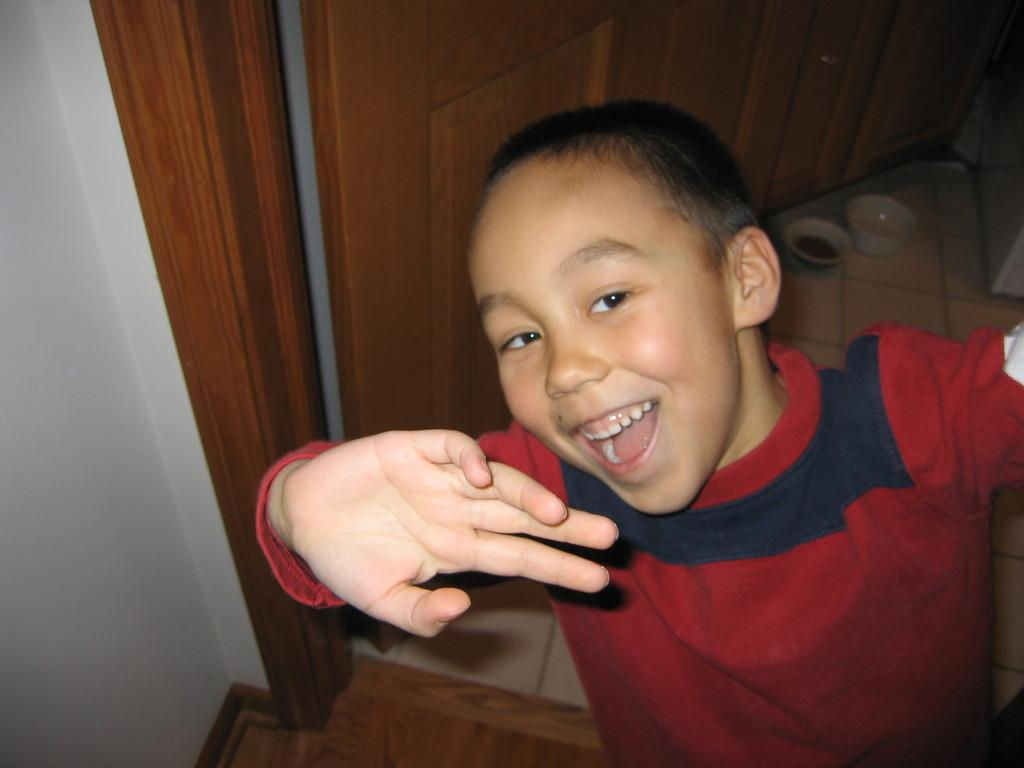What is the main subject of the picture? The main subject of the picture is a child. What is the child doing in the picture? The child is standing and laughing. What is located behind the child? There is a wall behind the child. What feature can be seen on the wall? There is a door present on the wall. What objects are on the floor near the child? There are two bowls on the floor. What type of pot is the child using to create music in the image? There is no pot or music present in the image; it only features a child standing and laughing, a wall with a door, and two bowls on the floor. 